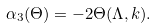Convert formula to latex. <formula><loc_0><loc_0><loc_500><loc_500>\alpha _ { 3 } ( \Theta ) = - 2 \Theta ( \Lambda , { k } ) .</formula> 